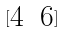<formula> <loc_0><loc_0><loc_500><loc_500>[ \begin{matrix} 4 & 6 \end{matrix} ]</formula> 